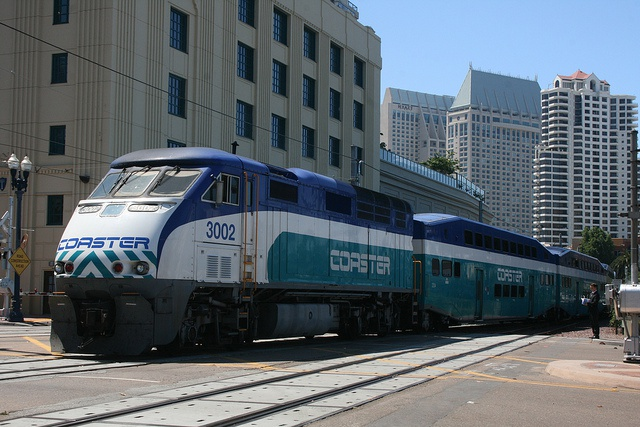Describe the objects in this image and their specific colors. I can see train in gray, black, navy, and darkgray tones and people in gray, black, maroon, and darkgray tones in this image. 